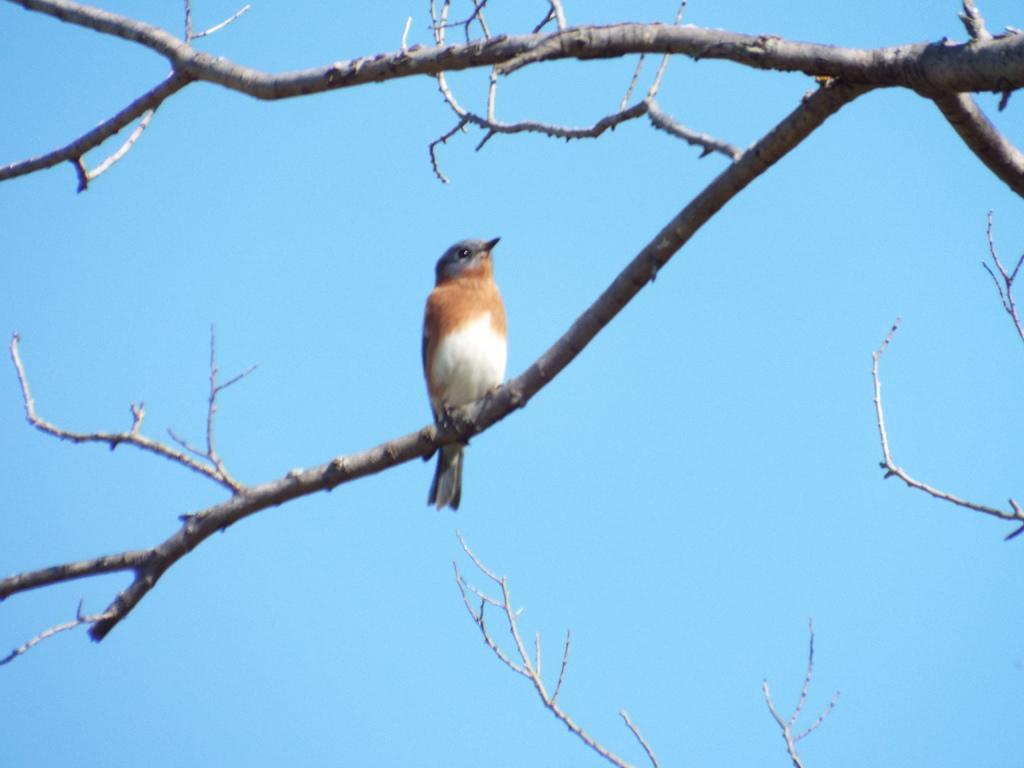Can you describe this image briefly? In this image I can see the bird and the bird is sitting on the dried tree. The bird is in white and brown color, background the sky is in blue color. 